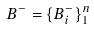Convert formula to latex. <formula><loc_0><loc_0><loc_500><loc_500>B ^ { - } = \{ B _ { i } ^ { - } \} _ { 1 } ^ { n }</formula> 